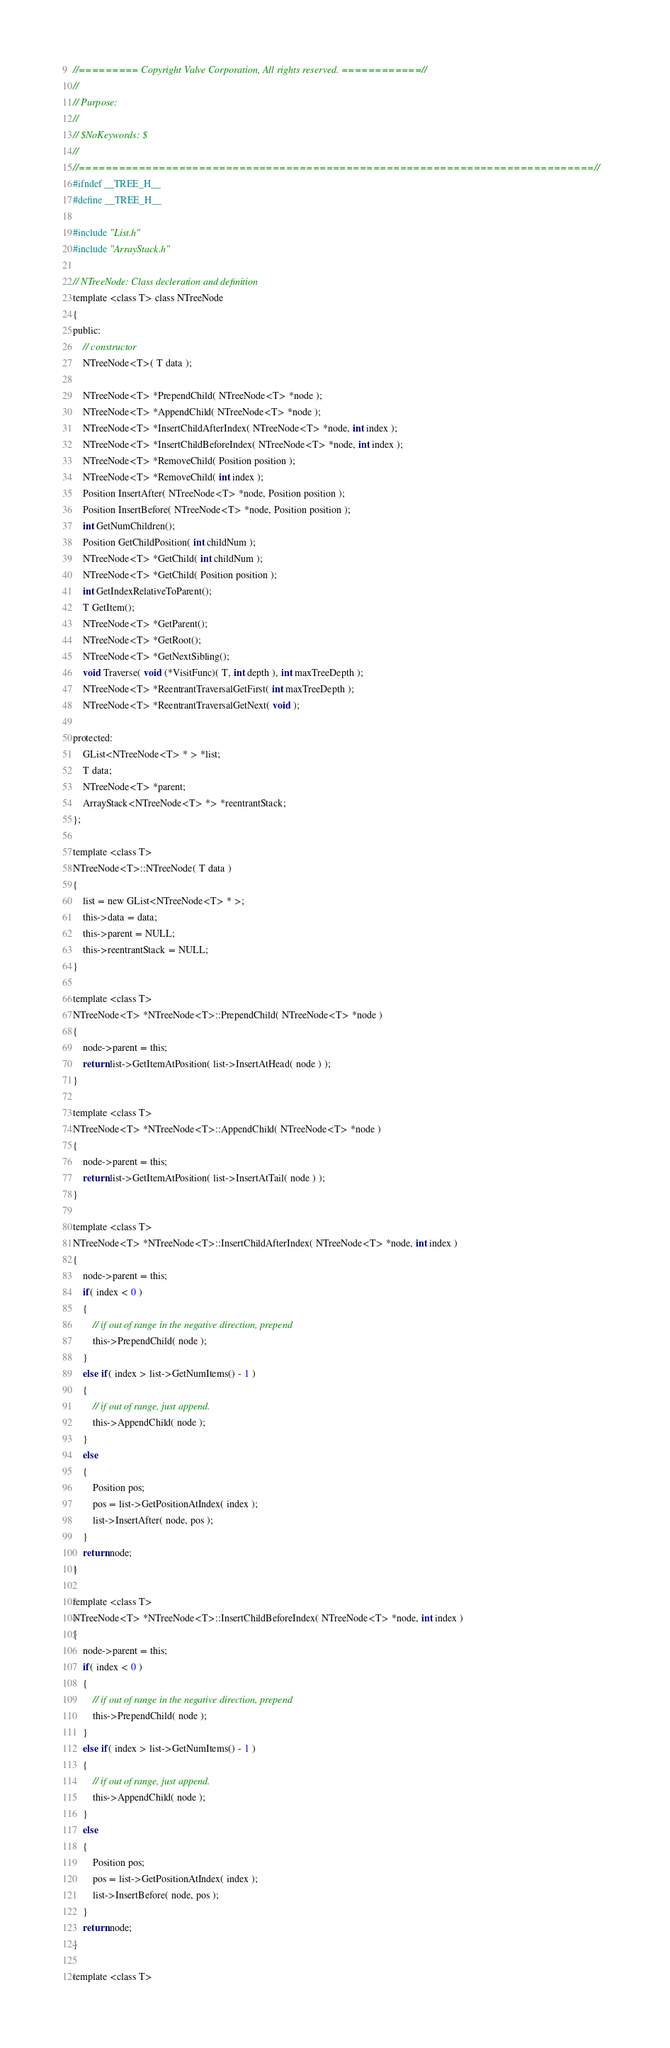<code> <loc_0><loc_0><loc_500><loc_500><_C_>//========= Copyright Valve Corporation, All rights reserved. ============//
//
// Purpose: 
//
// $NoKeywords: $
//
//=============================================================================//
#ifndef __TREE_H__
#define __TREE_H__

#include "List.h"
#include "ArrayStack.h"

// NTreeNode: Class decleration and definition
template <class T> class NTreeNode
{
public:
	// constructor
	NTreeNode<T>( T data );
	
	NTreeNode<T> *PrependChild( NTreeNode<T> *node );
	NTreeNode<T> *AppendChild( NTreeNode<T> *node );
	NTreeNode<T> *InsertChildAfterIndex( NTreeNode<T> *node, int index );
	NTreeNode<T> *InsertChildBeforeIndex( NTreeNode<T> *node, int index );
	NTreeNode<T> *RemoveChild( Position position );
	NTreeNode<T> *RemoveChild( int index );
	Position InsertAfter( NTreeNode<T> *node, Position position );
	Position InsertBefore( NTreeNode<T> *node, Position position );
	int GetNumChildren();
	Position GetChildPosition( int childNum );
	NTreeNode<T> *GetChild( int childNum );
	NTreeNode<T> *GetChild( Position position );
	int GetIndexRelativeToParent();
	T GetItem();
	NTreeNode<T> *GetParent();
	NTreeNode<T> *GetRoot();
	NTreeNode<T> *GetNextSibling();
	void Traverse( void (*VisitFunc)( T, int depth ), int maxTreeDepth );
	NTreeNode<T> *ReentrantTraversalGetFirst( int maxTreeDepth );
	NTreeNode<T> *ReentrantTraversalGetNext( void );
	
protected:
	GList<NTreeNode<T> * > *list;
	T data;
	NTreeNode<T> *parent;
	ArrayStack<NTreeNode<T> *> *reentrantStack;
};

template <class T>
NTreeNode<T>::NTreeNode( T data )
{
	list = new GList<NTreeNode<T> * >;
	this->data = data;
	this->parent = NULL;
	this->reentrantStack = NULL;
}

template <class T>
NTreeNode<T> *NTreeNode<T>::PrependChild( NTreeNode<T> *node )
{
	node->parent = this;
	return list->GetItemAtPosition( list->InsertAtHead( node ) );
}

template <class T>
NTreeNode<T> *NTreeNode<T>::AppendChild( NTreeNode<T> *node )
{
	node->parent = this;
	return list->GetItemAtPosition( list->InsertAtTail( node ) );
}

template <class T>
NTreeNode<T> *NTreeNode<T>::InsertChildAfterIndex( NTreeNode<T> *node, int index )
{
	node->parent = this;
	if( index < 0 )
	{
		// if out of range in the negative direction, prepend
		this->PrependChild( node );
	}
	else if( index > list->GetNumItems() - 1 )
	{
		// if out of range, just append.
		this->AppendChild( node );
	}
	else
	{
		Position pos;
		pos = list->GetPositionAtIndex( index );
		list->InsertAfter( node, pos );
	}
	return node;
}

template <class T>
NTreeNode<T> *NTreeNode<T>::InsertChildBeforeIndex( NTreeNode<T> *node, int index )
{
	node->parent = this;
	if( index < 0 )
	{
		// if out of range in the negative direction, prepend
		this->PrependChild( node );
	}
	else if( index > list->GetNumItems() - 1 )
	{
		// if out of range, just append.
		this->AppendChild( node );
	}
	else
	{
		Position pos;
		pos = list->GetPositionAtIndex( index );
		list->InsertBefore( node, pos );
	}
	return node;
}

template <class T></code> 